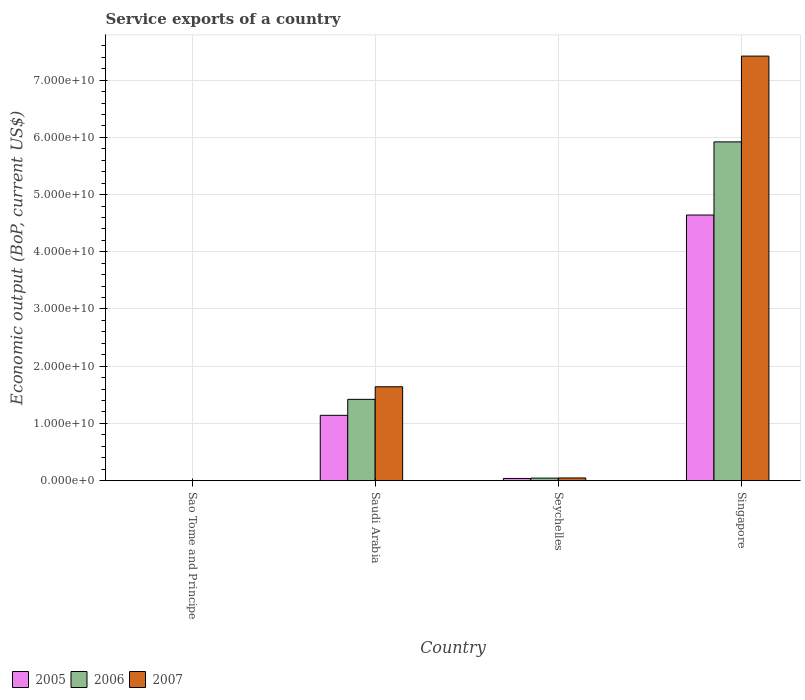How many different coloured bars are there?
Ensure brevity in your answer.  3. How many groups of bars are there?
Your response must be concise. 4. Are the number of bars on each tick of the X-axis equal?
Your answer should be compact. Yes. How many bars are there on the 3rd tick from the left?
Your response must be concise. 3. How many bars are there on the 1st tick from the right?
Make the answer very short. 3. What is the label of the 1st group of bars from the left?
Offer a very short reply. Sao Tome and Principe. What is the service exports in 2005 in Singapore?
Keep it short and to the point. 4.64e+1. Across all countries, what is the maximum service exports in 2007?
Your answer should be very brief. 7.42e+1. Across all countries, what is the minimum service exports in 2007?
Provide a succinct answer. 6.70e+06. In which country was the service exports in 2006 maximum?
Ensure brevity in your answer.  Singapore. In which country was the service exports in 2005 minimum?
Your answer should be compact. Sao Tome and Principe. What is the total service exports in 2005 in the graph?
Provide a short and direct response. 5.82e+1. What is the difference between the service exports in 2006 in Sao Tome and Principe and that in Seychelles?
Make the answer very short. -4.23e+08. What is the difference between the service exports in 2006 in Seychelles and the service exports in 2007 in Sao Tome and Principe?
Give a very brief answer. 4.24e+08. What is the average service exports in 2007 per country?
Ensure brevity in your answer.  2.28e+1. What is the difference between the service exports of/in 2005 and service exports of/in 2007 in Saudi Arabia?
Offer a very short reply. -4.99e+09. What is the ratio of the service exports in 2007 in Saudi Arabia to that in Seychelles?
Offer a very short reply. 35.96. Is the service exports in 2005 in Sao Tome and Principe less than that in Saudi Arabia?
Provide a succinct answer. Yes. What is the difference between the highest and the second highest service exports in 2007?
Your response must be concise. 7.38e+1. What is the difference between the highest and the lowest service exports in 2005?
Provide a short and direct response. 4.64e+1. Is the sum of the service exports in 2005 in Sao Tome and Principe and Saudi Arabia greater than the maximum service exports in 2006 across all countries?
Give a very brief answer. No. What does the 3rd bar from the left in Saudi Arabia represents?
Ensure brevity in your answer.  2007. What does the 2nd bar from the right in Singapore represents?
Provide a short and direct response. 2006. Is it the case that in every country, the sum of the service exports in 2007 and service exports in 2006 is greater than the service exports in 2005?
Provide a succinct answer. Yes. Are all the bars in the graph horizontal?
Make the answer very short. No. How many countries are there in the graph?
Give a very brief answer. 4. What is the difference between two consecutive major ticks on the Y-axis?
Ensure brevity in your answer.  1.00e+1. Does the graph contain any zero values?
Make the answer very short. No. Does the graph contain grids?
Offer a very short reply. Yes. Where does the legend appear in the graph?
Keep it short and to the point. Bottom left. How many legend labels are there?
Your response must be concise. 3. How are the legend labels stacked?
Offer a terse response. Horizontal. What is the title of the graph?
Offer a very short reply. Service exports of a country. What is the label or title of the Y-axis?
Your answer should be compact. Economic output (BoP, current US$). What is the Economic output (BoP, current US$) of 2005 in Sao Tome and Principe?
Provide a succinct answer. 9.15e+06. What is the Economic output (BoP, current US$) of 2006 in Sao Tome and Principe?
Ensure brevity in your answer.  8.40e+06. What is the Economic output (BoP, current US$) in 2007 in Sao Tome and Principe?
Provide a short and direct response. 6.70e+06. What is the Economic output (BoP, current US$) in 2005 in Saudi Arabia?
Ensure brevity in your answer.  1.14e+1. What is the Economic output (BoP, current US$) in 2006 in Saudi Arabia?
Keep it short and to the point. 1.42e+1. What is the Economic output (BoP, current US$) in 2007 in Saudi Arabia?
Give a very brief answer. 1.64e+1. What is the Economic output (BoP, current US$) of 2005 in Seychelles?
Offer a very short reply. 3.70e+08. What is the Economic output (BoP, current US$) in 2006 in Seychelles?
Ensure brevity in your answer.  4.31e+08. What is the Economic output (BoP, current US$) of 2007 in Seychelles?
Your answer should be very brief. 4.56e+08. What is the Economic output (BoP, current US$) of 2005 in Singapore?
Your answer should be very brief. 4.64e+1. What is the Economic output (BoP, current US$) in 2006 in Singapore?
Offer a very short reply. 5.92e+1. What is the Economic output (BoP, current US$) in 2007 in Singapore?
Offer a terse response. 7.42e+1. Across all countries, what is the maximum Economic output (BoP, current US$) in 2005?
Give a very brief answer. 4.64e+1. Across all countries, what is the maximum Economic output (BoP, current US$) of 2006?
Provide a succinct answer. 5.92e+1. Across all countries, what is the maximum Economic output (BoP, current US$) of 2007?
Provide a succinct answer. 7.42e+1. Across all countries, what is the minimum Economic output (BoP, current US$) in 2005?
Offer a very short reply. 9.15e+06. Across all countries, what is the minimum Economic output (BoP, current US$) in 2006?
Your answer should be very brief. 8.40e+06. Across all countries, what is the minimum Economic output (BoP, current US$) in 2007?
Provide a succinct answer. 6.70e+06. What is the total Economic output (BoP, current US$) of 2005 in the graph?
Provide a short and direct response. 5.82e+1. What is the total Economic output (BoP, current US$) of 2006 in the graph?
Provide a short and direct response. 7.39e+1. What is the total Economic output (BoP, current US$) in 2007 in the graph?
Make the answer very short. 9.11e+1. What is the difference between the Economic output (BoP, current US$) in 2005 in Sao Tome and Principe and that in Saudi Arabia?
Your answer should be compact. -1.14e+1. What is the difference between the Economic output (BoP, current US$) of 2006 in Sao Tome and Principe and that in Saudi Arabia?
Make the answer very short. -1.42e+1. What is the difference between the Economic output (BoP, current US$) of 2007 in Sao Tome and Principe and that in Saudi Arabia?
Make the answer very short. -1.64e+1. What is the difference between the Economic output (BoP, current US$) in 2005 in Sao Tome and Principe and that in Seychelles?
Your answer should be very brief. -3.60e+08. What is the difference between the Economic output (BoP, current US$) in 2006 in Sao Tome and Principe and that in Seychelles?
Your response must be concise. -4.23e+08. What is the difference between the Economic output (BoP, current US$) in 2007 in Sao Tome and Principe and that in Seychelles?
Your answer should be compact. -4.49e+08. What is the difference between the Economic output (BoP, current US$) in 2005 in Sao Tome and Principe and that in Singapore?
Your response must be concise. -4.64e+1. What is the difference between the Economic output (BoP, current US$) of 2006 in Sao Tome and Principe and that in Singapore?
Provide a short and direct response. -5.92e+1. What is the difference between the Economic output (BoP, current US$) in 2007 in Sao Tome and Principe and that in Singapore?
Ensure brevity in your answer.  -7.42e+1. What is the difference between the Economic output (BoP, current US$) in 2005 in Saudi Arabia and that in Seychelles?
Provide a short and direct response. 1.10e+1. What is the difference between the Economic output (BoP, current US$) of 2006 in Saudi Arabia and that in Seychelles?
Offer a terse response. 1.38e+1. What is the difference between the Economic output (BoP, current US$) of 2007 in Saudi Arabia and that in Seychelles?
Make the answer very short. 1.59e+1. What is the difference between the Economic output (BoP, current US$) in 2005 in Saudi Arabia and that in Singapore?
Offer a very short reply. -3.50e+1. What is the difference between the Economic output (BoP, current US$) of 2006 in Saudi Arabia and that in Singapore?
Give a very brief answer. -4.50e+1. What is the difference between the Economic output (BoP, current US$) of 2007 in Saudi Arabia and that in Singapore?
Give a very brief answer. -5.78e+1. What is the difference between the Economic output (BoP, current US$) of 2005 in Seychelles and that in Singapore?
Give a very brief answer. -4.61e+1. What is the difference between the Economic output (BoP, current US$) in 2006 in Seychelles and that in Singapore?
Your answer should be compact. -5.88e+1. What is the difference between the Economic output (BoP, current US$) in 2007 in Seychelles and that in Singapore?
Keep it short and to the point. -7.38e+1. What is the difference between the Economic output (BoP, current US$) of 2005 in Sao Tome and Principe and the Economic output (BoP, current US$) of 2006 in Saudi Arabia?
Keep it short and to the point. -1.42e+1. What is the difference between the Economic output (BoP, current US$) in 2005 in Sao Tome and Principe and the Economic output (BoP, current US$) in 2007 in Saudi Arabia?
Your answer should be compact. -1.64e+1. What is the difference between the Economic output (BoP, current US$) in 2006 in Sao Tome and Principe and the Economic output (BoP, current US$) in 2007 in Saudi Arabia?
Ensure brevity in your answer.  -1.64e+1. What is the difference between the Economic output (BoP, current US$) in 2005 in Sao Tome and Principe and the Economic output (BoP, current US$) in 2006 in Seychelles?
Your answer should be very brief. -4.22e+08. What is the difference between the Economic output (BoP, current US$) in 2005 in Sao Tome and Principe and the Economic output (BoP, current US$) in 2007 in Seychelles?
Offer a very short reply. -4.47e+08. What is the difference between the Economic output (BoP, current US$) of 2006 in Sao Tome and Principe and the Economic output (BoP, current US$) of 2007 in Seychelles?
Make the answer very short. -4.48e+08. What is the difference between the Economic output (BoP, current US$) of 2005 in Sao Tome and Principe and the Economic output (BoP, current US$) of 2006 in Singapore?
Keep it short and to the point. -5.92e+1. What is the difference between the Economic output (BoP, current US$) in 2005 in Sao Tome and Principe and the Economic output (BoP, current US$) in 2007 in Singapore?
Provide a short and direct response. -7.42e+1. What is the difference between the Economic output (BoP, current US$) of 2006 in Sao Tome and Principe and the Economic output (BoP, current US$) of 2007 in Singapore?
Ensure brevity in your answer.  -7.42e+1. What is the difference between the Economic output (BoP, current US$) in 2005 in Saudi Arabia and the Economic output (BoP, current US$) in 2006 in Seychelles?
Offer a very short reply. 1.10e+1. What is the difference between the Economic output (BoP, current US$) in 2005 in Saudi Arabia and the Economic output (BoP, current US$) in 2007 in Seychelles?
Your answer should be compact. 1.10e+1. What is the difference between the Economic output (BoP, current US$) in 2006 in Saudi Arabia and the Economic output (BoP, current US$) in 2007 in Seychelles?
Your answer should be compact. 1.37e+1. What is the difference between the Economic output (BoP, current US$) in 2005 in Saudi Arabia and the Economic output (BoP, current US$) in 2006 in Singapore?
Offer a very short reply. -4.78e+1. What is the difference between the Economic output (BoP, current US$) of 2005 in Saudi Arabia and the Economic output (BoP, current US$) of 2007 in Singapore?
Offer a very short reply. -6.28e+1. What is the difference between the Economic output (BoP, current US$) of 2006 in Saudi Arabia and the Economic output (BoP, current US$) of 2007 in Singapore?
Provide a succinct answer. -6.00e+1. What is the difference between the Economic output (BoP, current US$) in 2005 in Seychelles and the Economic output (BoP, current US$) in 2006 in Singapore?
Ensure brevity in your answer.  -5.88e+1. What is the difference between the Economic output (BoP, current US$) of 2005 in Seychelles and the Economic output (BoP, current US$) of 2007 in Singapore?
Ensure brevity in your answer.  -7.38e+1. What is the difference between the Economic output (BoP, current US$) in 2006 in Seychelles and the Economic output (BoP, current US$) in 2007 in Singapore?
Provide a succinct answer. -7.38e+1. What is the average Economic output (BoP, current US$) in 2005 per country?
Ensure brevity in your answer.  1.46e+1. What is the average Economic output (BoP, current US$) of 2006 per country?
Keep it short and to the point. 1.85e+1. What is the average Economic output (BoP, current US$) in 2007 per country?
Offer a terse response. 2.28e+1. What is the difference between the Economic output (BoP, current US$) in 2005 and Economic output (BoP, current US$) in 2006 in Sao Tome and Principe?
Your answer should be compact. 7.49e+05. What is the difference between the Economic output (BoP, current US$) in 2005 and Economic output (BoP, current US$) in 2007 in Sao Tome and Principe?
Provide a short and direct response. 2.45e+06. What is the difference between the Economic output (BoP, current US$) of 2006 and Economic output (BoP, current US$) of 2007 in Sao Tome and Principe?
Keep it short and to the point. 1.70e+06. What is the difference between the Economic output (BoP, current US$) in 2005 and Economic output (BoP, current US$) in 2006 in Saudi Arabia?
Your response must be concise. -2.79e+09. What is the difference between the Economic output (BoP, current US$) in 2005 and Economic output (BoP, current US$) in 2007 in Saudi Arabia?
Give a very brief answer. -4.99e+09. What is the difference between the Economic output (BoP, current US$) in 2006 and Economic output (BoP, current US$) in 2007 in Saudi Arabia?
Give a very brief answer. -2.20e+09. What is the difference between the Economic output (BoP, current US$) in 2005 and Economic output (BoP, current US$) in 2006 in Seychelles?
Give a very brief answer. -6.16e+07. What is the difference between the Economic output (BoP, current US$) in 2005 and Economic output (BoP, current US$) in 2007 in Seychelles?
Provide a succinct answer. -8.66e+07. What is the difference between the Economic output (BoP, current US$) of 2006 and Economic output (BoP, current US$) of 2007 in Seychelles?
Your response must be concise. -2.50e+07. What is the difference between the Economic output (BoP, current US$) of 2005 and Economic output (BoP, current US$) of 2006 in Singapore?
Ensure brevity in your answer.  -1.28e+1. What is the difference between the Economic output (BoP, current US$) in 2005 and Economic output (BoP, current US$) in 2007 in Singapore?
Give a very brief answer. -2.78e+1. What is the difference between the Economic output (BoP, current US$) of 2006 and Economic output (BoP, current US$) of 2007 in Singapore?
Provide a short and direct response. -1.50e+1. What is the ratio of the Economic output (BoP, current US$) of 2005 in Sao Tome and Principe to that in Saudi Arabia?
Offer a terse response. 0. What is the ratio of the Economic output (BoP, current US$) in 2006 in Sao Tome and Principe to that in Saudi Arabia?
Offer a terse response. 0. What is the ratio of the Economic output (BoP, current US$) in 2005 in Sao Tome and Principe to that in Seychelles?
Give a very brief answer. 0.02. What is the ratio of the Economic output (BoP, current US$) of 2006 in Sao Tome and Principe to that in Seychelles?
Provide a short and direct response. 0.02. What is the ratio of the Economic output (BoP, current US$) in 2007 in Sao Tome and Principe to that in Seychelles?
Make the answer very short. 0.01. What is the ratio of the Economic output (BoP, current US$) of 2007 in Sao Tome and Principe to that in Singapore?
Make the answer very short. 0. What is the ratio of the Economic output (BoP, current US$) of 2005 in Saudi Arabia to that in Seychelles?
Your response must be concise. 30.87. What is the ratio of the Economic output (BoP, current US$) of 2006 in Saudi Arabia to that in Seychelles?
Your answer should be compact. 32.94. What is the ratio of the Economic output (BoP, current US$) of 2007 in Saudi Arabia to that in Seychelles?
Your answer should be very brief. 35.96. What is the ratio of the Economic output (BoP, current US$) of 2005 in Saudi Arabia to that in Singapore?
Provide a succinct answer. 0.25. What is the ratio of the Economic output (BoP, current US$) of 2006 in Saudi Arabia to that in Singapore?
Ensure brevity in your answer.  0.24. What is the ratio of the Economic output (BoP, current US$) of 2007 in Saudi Arabia to that in Singapore?
Offer a very short reply. 0.22. What is the ratio of the Economic output (BoP, current US$) in 2005 in Seychelles to that in Singapore?
Your response must be concise. 0.01. What is the ratio of the Economic output (BoP, current US$) of 2006 in Seychelles to that in Singapore?
Your answer should be compact. 0.01. What is the ratio of the Economic output (BoP, current US$) of 2007 in Seychelles to that in Singapore?
Give a very brief answer. 0.01. What is the difference between the highest and the second highest Economic output (BoP, current US$) of 2005?
Offer a terse response. 3.50e+1. What is the difference between the highest and the second highest Economic output (BoP, current US$) of 2006?
Your answer should be very brief. 4.50e+1. What is the difference between the highest and the second highest Economic output (BoP, current US$) of 2007?
Ensure brevity in your answer.  5.78e+1. What is the difference between the highest and the lowest Economic output (BoP, current US$) of 2005?
Make the answer very short. 4.64e+1. What is the difference between the highest and the lowest Economic output (BoP, current US$) in 2006?
Offer a very short reply. 5.92e+1. What is the difference between the highest and the lowest Economic output (BoP, current US$) in 2007?
Your answer should be compact. 7.42e+1. 